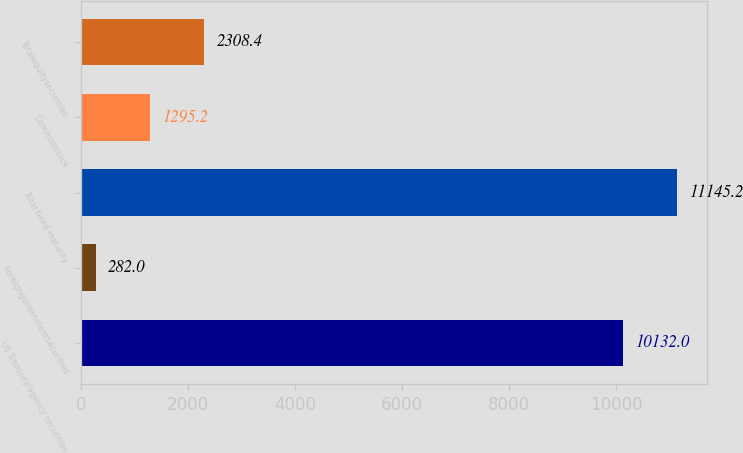<chart> <loc_0><loc_0><loc_500><loc_500><bar_chart><fcel>US Treasury/agency securities<fcel>Foreigngovernmentsecurities<fcel>Total fixed maturity<fcel>Commonstock<fcel>Totalequitysecurities<nl><fcel>10132<fcel>282<fcel>11145.2<fcel>1295.2<fcel>2308.4<nl></chart> 